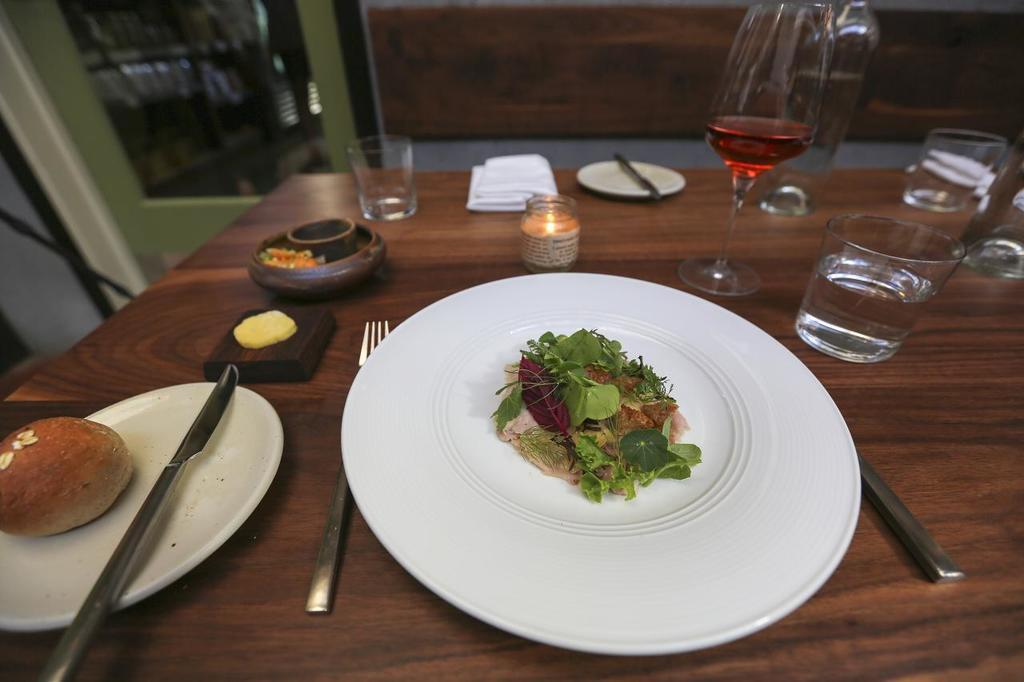What is the main piece of furniture in the image? There is a table in the image. How many plates are on the table? There are 2 plates on the table. What is in the plates? There is food in the plates. What utensils are on the table? There is a knife and a fork on the table. What is used for drinking in the image? There are glasses on the table. What is used for wiping or cleaning in the image? There is a napkin on the table. What can be seen in the background of the image? There is a wall in the background of the image. How many clams are on the table? There are no clams visible on the table in the image. 